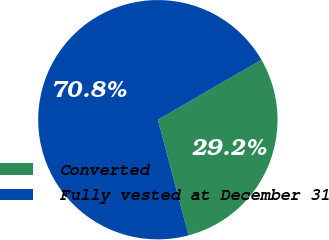Convert chart to OTSL. <chart><loc_0><loc_0><loc_500><loc_500><pie_chart><fcel>Converted<fcel>Fully vested at December 31<nl><fcel>29.22%<fcel>70.78%<nl></chart> 